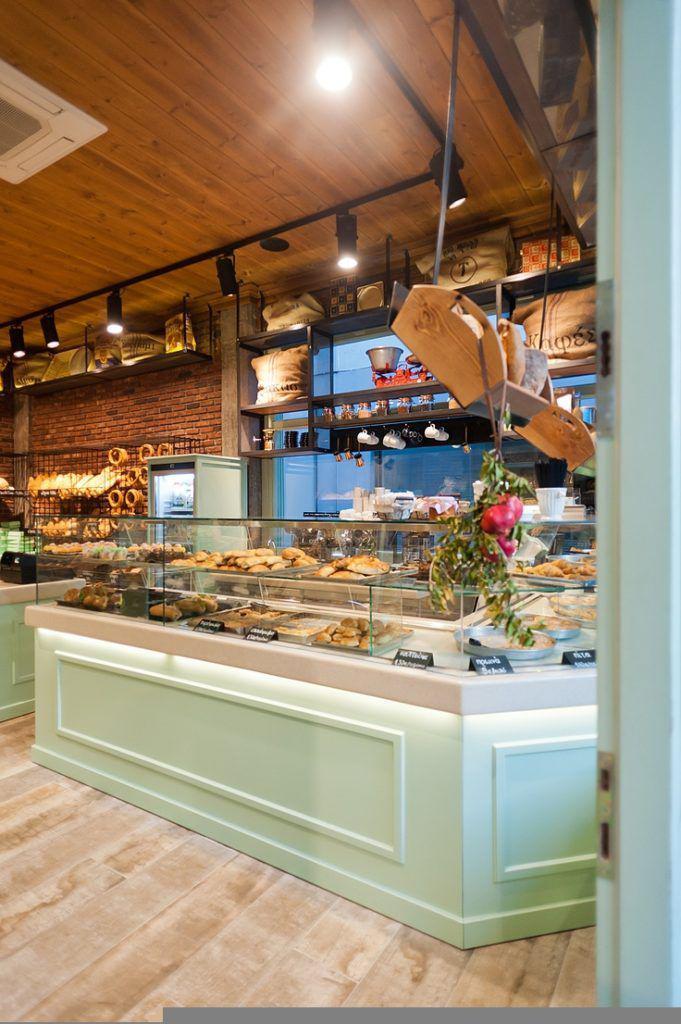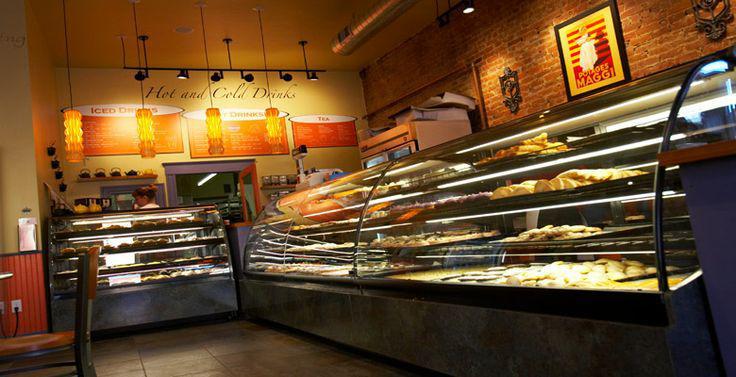The first image is the image on the left, the second image is the image on the right. For the images shown, is this caption "One display cabinet is a soft green color." true? Answer yes or no. Yes. 